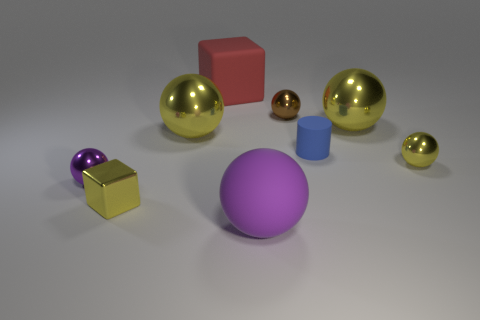Subtract all cyan cylinders. How many yellow balls are left? 3 Subtract all big metallic spheres. How many spheres are left? 4 Subtract all purple balls. How many balls are left? 4 Subtract all red spheres. Subtract all yellow cubes. How many spheres are left? 6 Add 1 brown metallic balls. How many objects exist? 10 Subtract all cubes. How many objects are left? 7 Subtract 0 brown cubes. How many objects are left? 9 Subtract all matte cubes. Subtract all purple spheres. How many objects are left? 6 Add 5 small yellow balls. How many small yellow balls are left? 6 Add 2 large gray rubber cubes. How many large gray rubber cubes exist? 2 